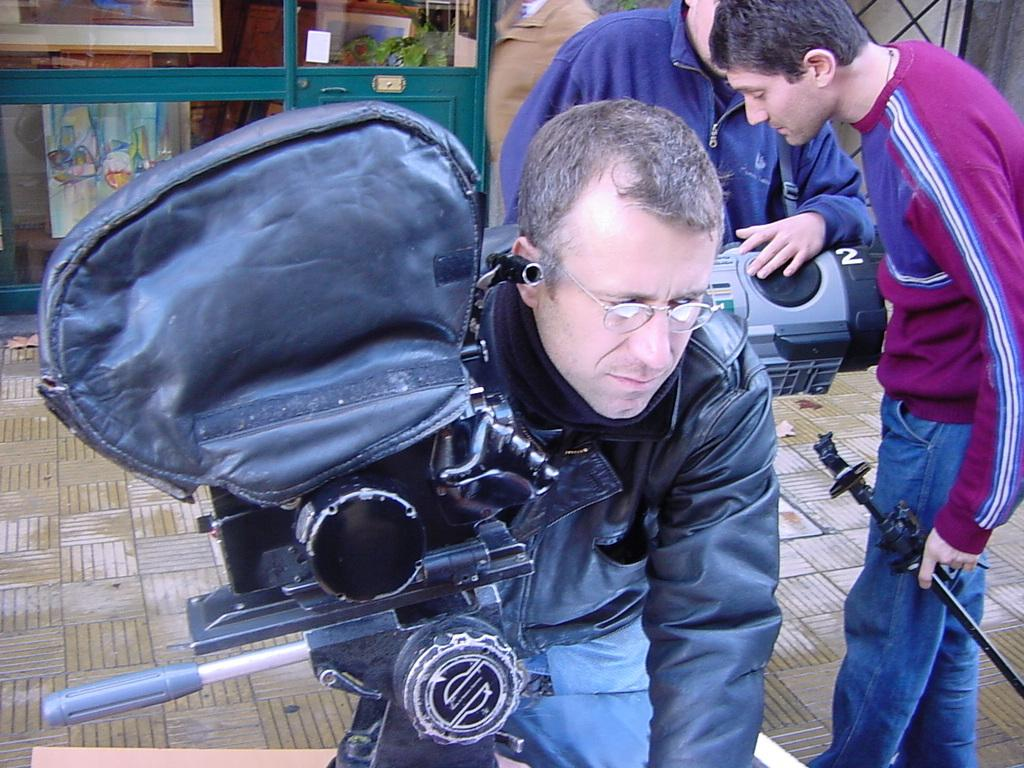What are the people in the image doing? The people in the image are standing on the floor. What objects can be seen in the hands of the people? Cameras are visible in the image. What can be seen in the background of the image? There is a poster and a frame in the background of the image. How many sheep are visible in the image? There are no sheep present in the image. What rule is being enforced by the people in the image? There is no indication of a rule being enforced in the image. 